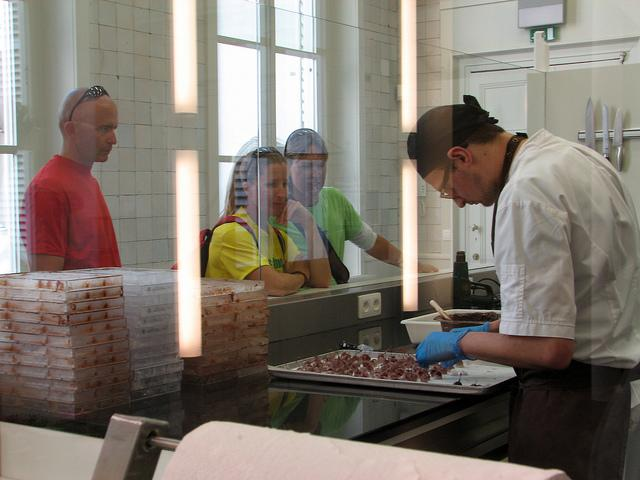What is the man using to cook? Please explain your reasoning. chocolate. This is an ingredient in the dish he is making 